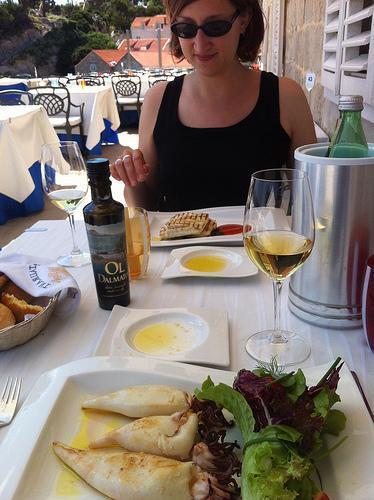How many people are see?
Give a very brief answer. 1. How many plates are served?
Give a very brief answer. 2. How many glasses of wine in the picture?
Give a very brief answer. 2. 